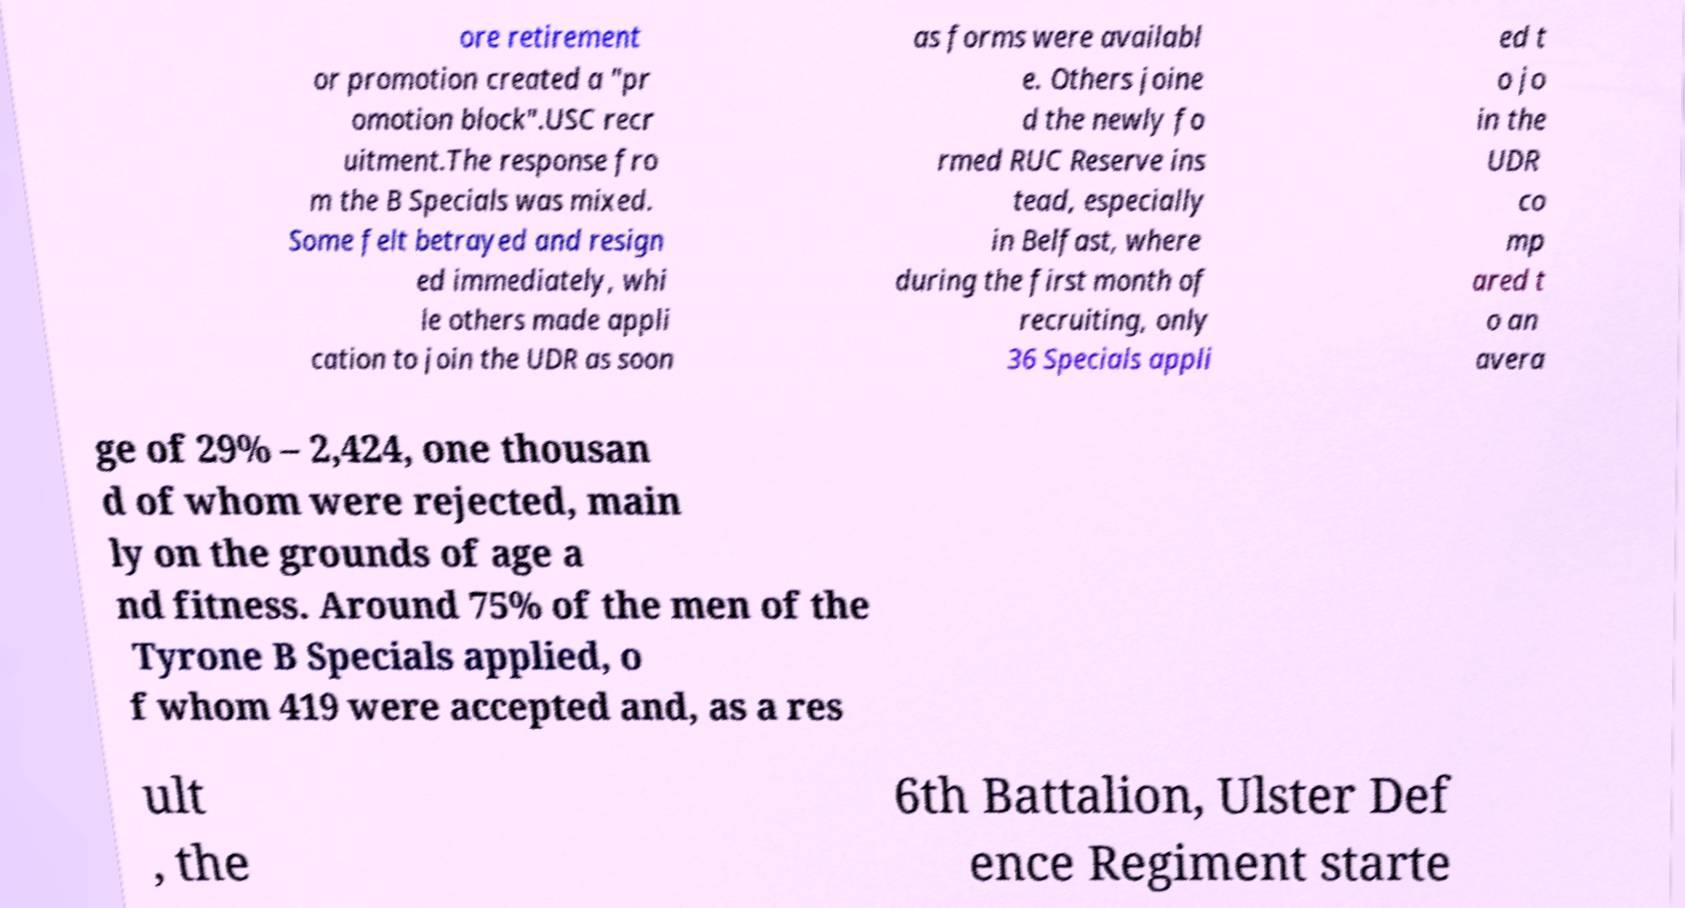Could you extract and type out the text from this image? ore retirement or promotion created a "pr omotion block".USC recr uitment.The response fro m the B Specials was mixed. Some felt betrayed and resign ed immediately, whi le others made appli cation to join the UDR as soon as forms were availabl e. Others joine d the newly fo rmed RUC Reserve ins tead, especially in Belfast, where during the first month of recruiting, only 36 Specials appli ed t o jo in the UDR co mp ared t o an avera ge of 29% – 2,424, one thousan d of whom were rejected, main ly on the grounds of age a nd fitness. Around 75% of the men of the Tyrone B Specials applied, o f whom 419 were accepted and, as a res ult , the 6th Battalion, Ulster Def ence Regiment starte 